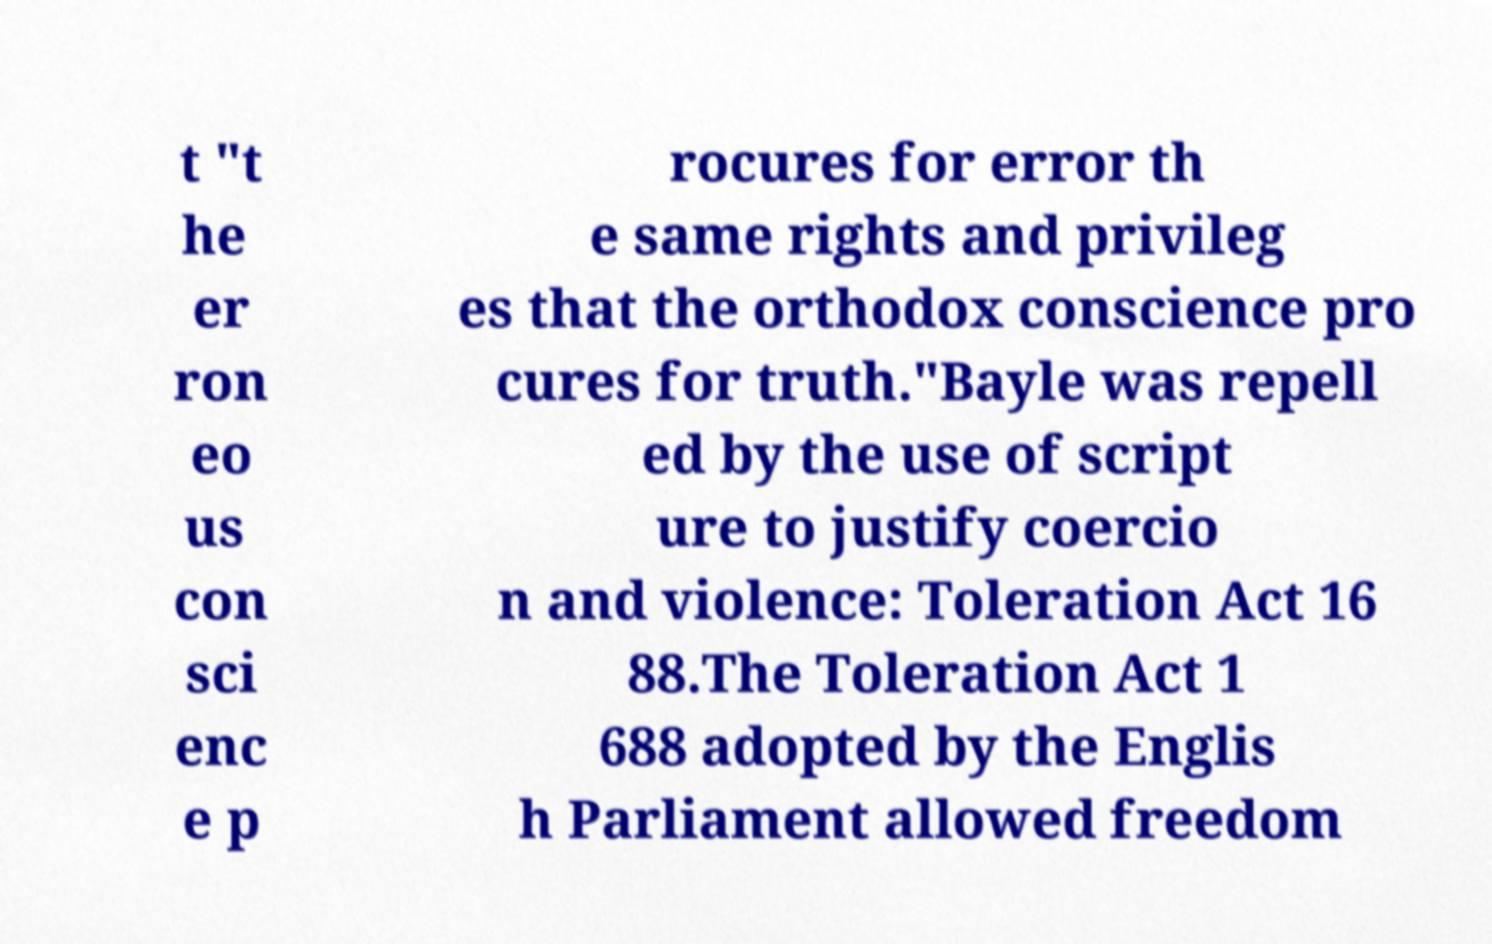Could you assist in decoding the text presented in this image and type it out clearly? t "t he er ron eo us con sci enc e p rocures for error th e same rights and privileg es that the orthodox conscience pro cures for truth."Bayle was repell ed by the use of script ure to justify coercio n and violence: Toleration Act 16 88.The Toleration Act 1 688 adopted by the Englis h Parliament allowed freedom 